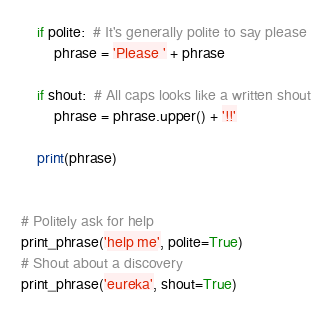<code> <loc_0><loc_0><loc_500><loc_500><_Python_>    if polite:  # It's generally polite to say please
        phrase = 'Please ' + phrase

    if shout:  # All caps looks like a written shout
        phrase = phrase.upper() + '!!'

    print(phrase)


# Politely ask for help
print_phrase('help me', polite=True)
# Shout about a discovery
print_phrase('eureka', shout=True)
</code> 